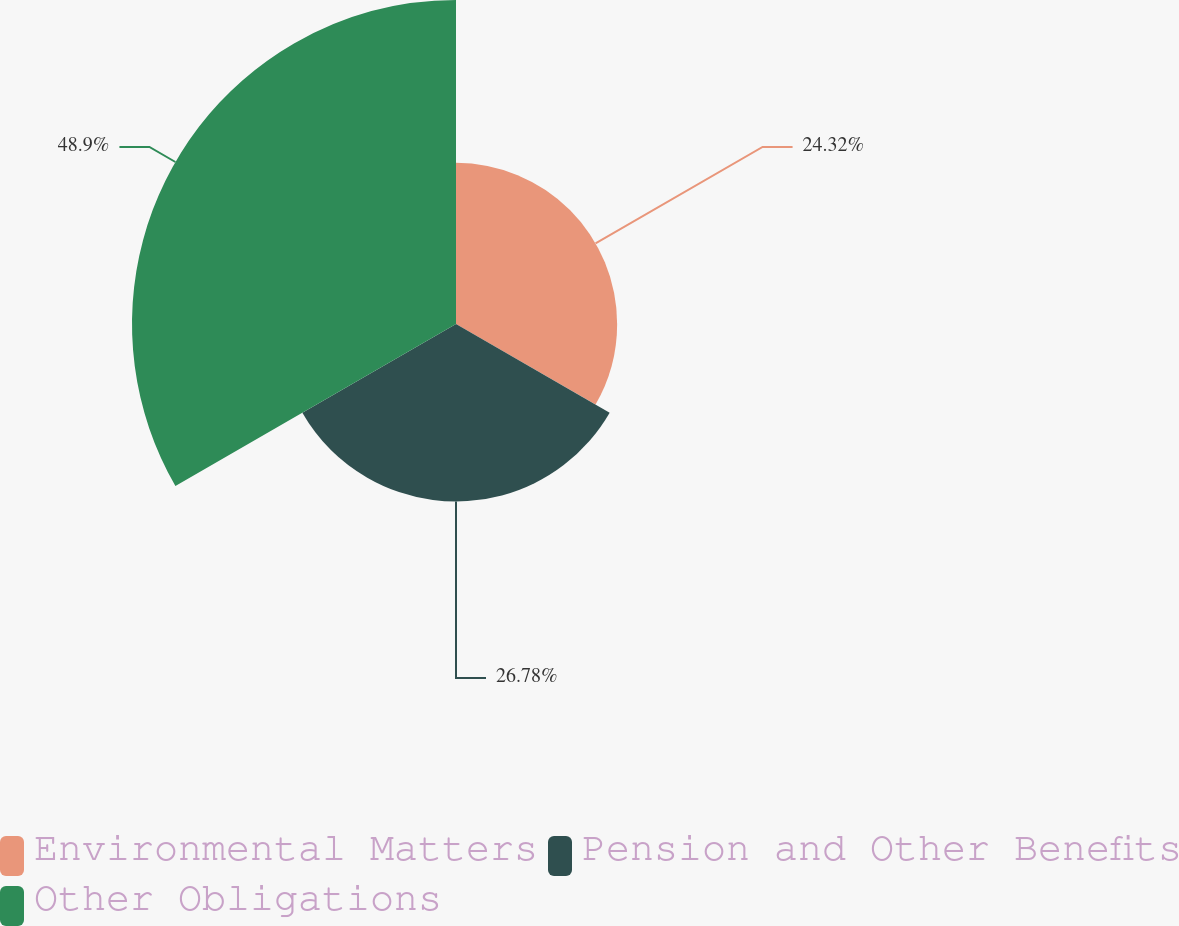Convert chart to OTSL. <chart><loc_0><loc_0><loc_500><loc_500><pie_chart><fcel>Environmental Matters<fcel>Pension and Other Benefits<fcel>Other Obligations<nl><fcel>24.32%<fcel>26.78%<fcel>48.9%<nl></chart> 